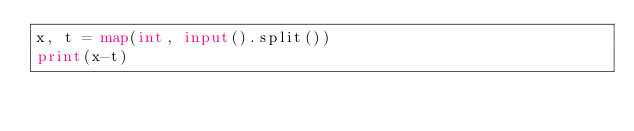Convert code to text. <code><loc_0><loc_0><loc_500><loc_500><_Python_>x, t = map(int, input().split())
print(x-t)</code> 